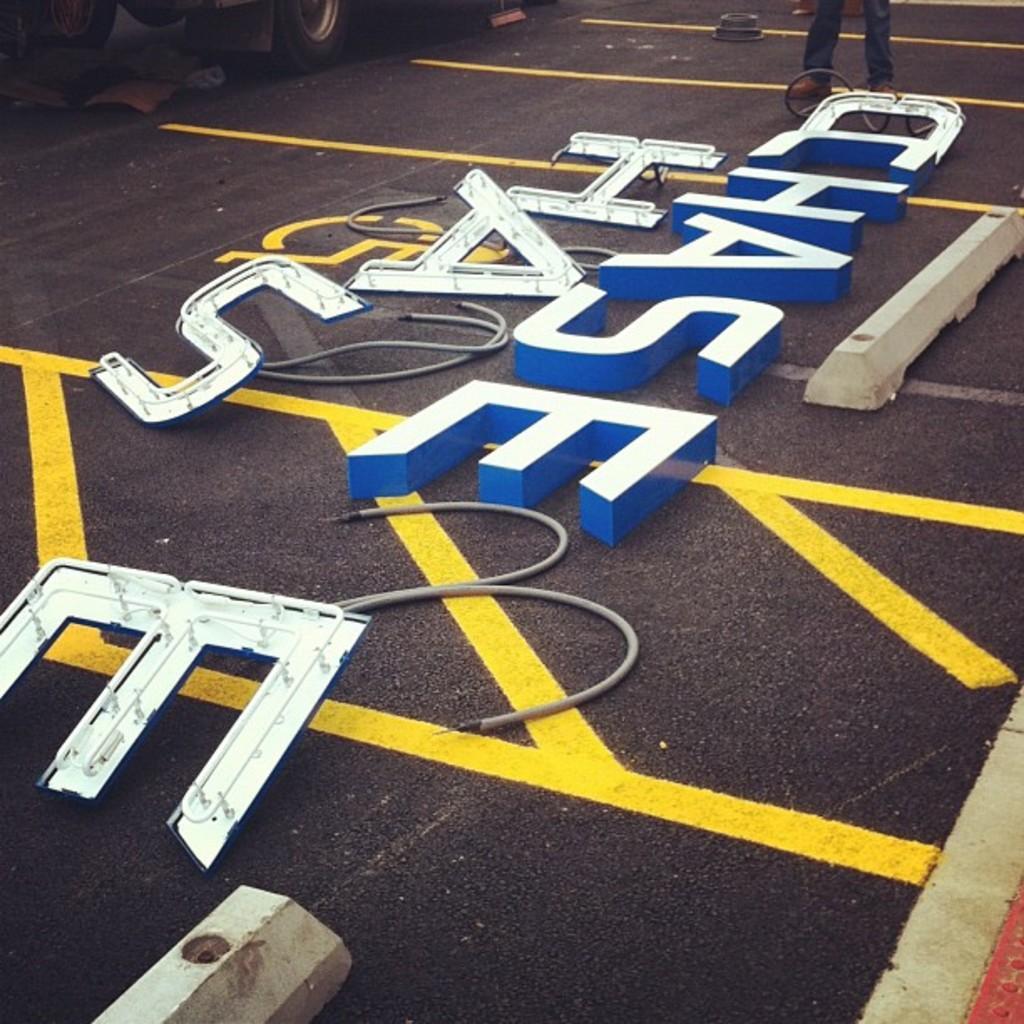In one or two sentences, can you explain what this image depicts? In this picture we can see few digital letters on the road, in the background we can see a vehicle and legs of a person. 